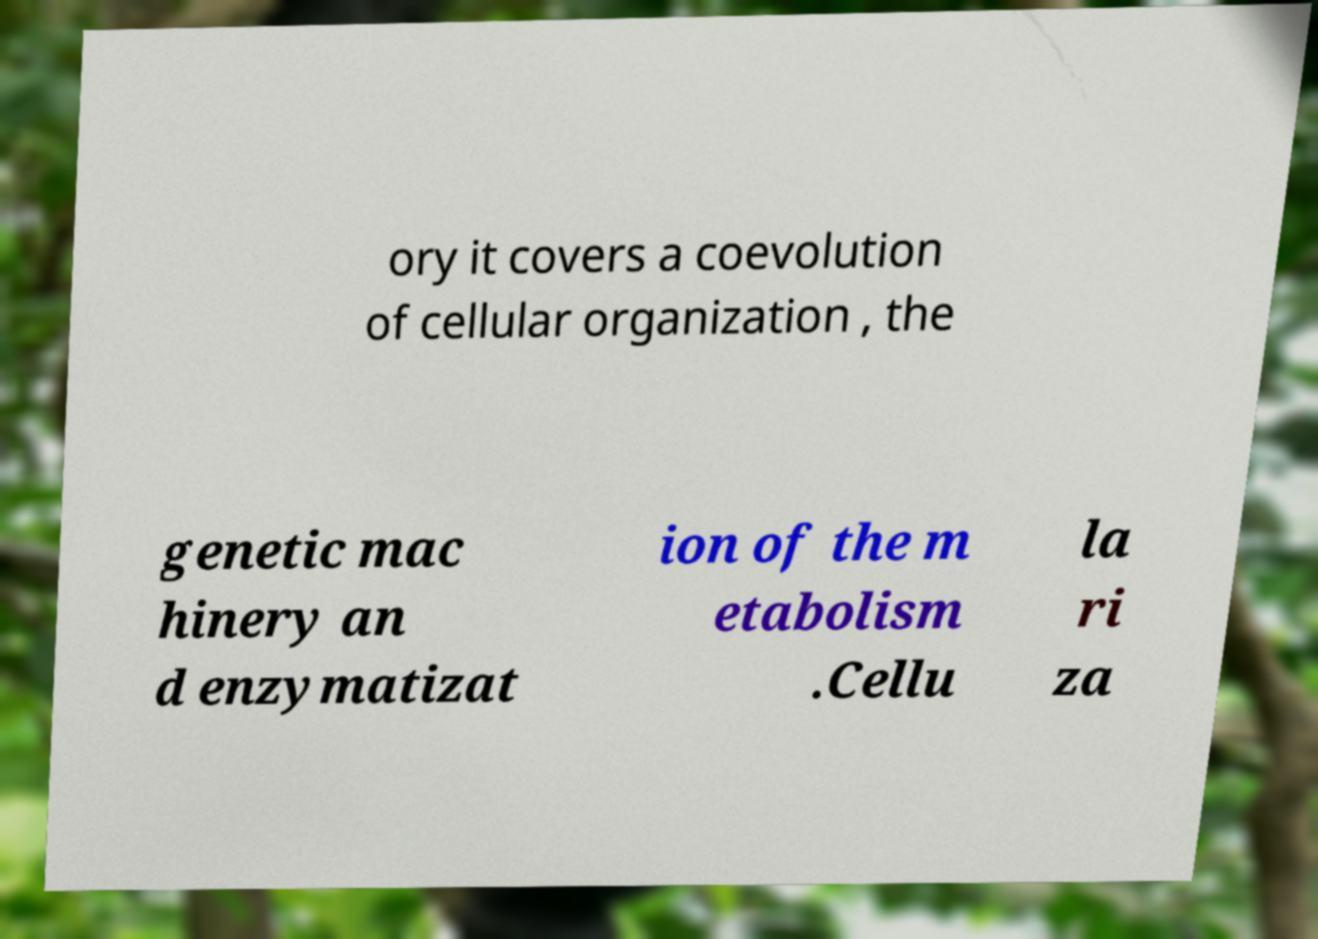Could you assist in decoding the text presented in this image and type it out clearly? ory it covers a coevolution of cellular organization , the genetic mac hinery an d enzymatizat ion of the m etabolism .Cellu la ri za 